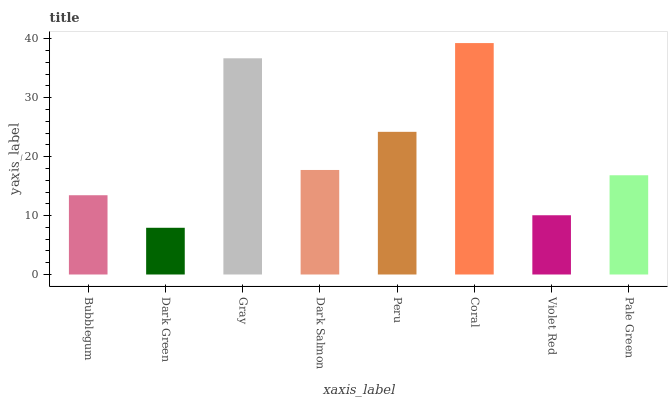Is Gray the minimum?
Answer yes or no. No. Is Gray the maximum?
Answer yes or no. No. Is Gray greater than Dark Green?
Answer yes or no. Yes. Is Dark Green less than Gray?
Answer yes or no. Yes. Is Dark Green greater than Gray?
Answer yes or no. No. Is Gray less than Dark Green?
Answer yes or no. No. Is Dark Salmon the high median?
Answer yes or no. Yes. Is Pale Green the low median?
Answer yes or no. Yes. Is Peru the high median?
Answer yes or no. No. Is Violet Red the low median?
Answer yes or no. No. 